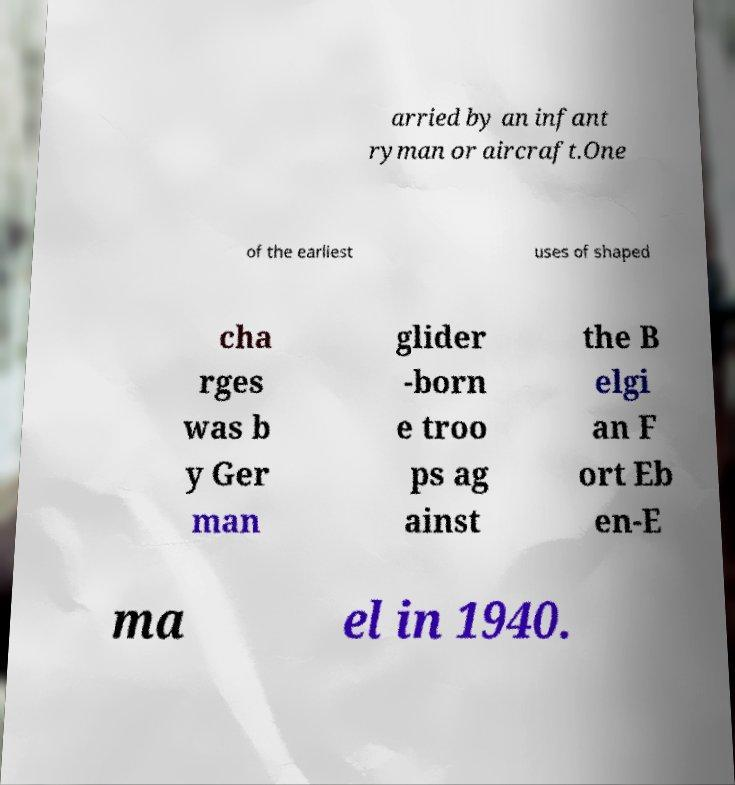Can you accurately transcribe the text from the provided image for me? arried by an infant ryman or aircraft.One of the earliest uses of shaped cha rges was b y Ger man glider -born e troo ps ag ainst the B elgi an F ort Eb en-E ma el in 1940. 